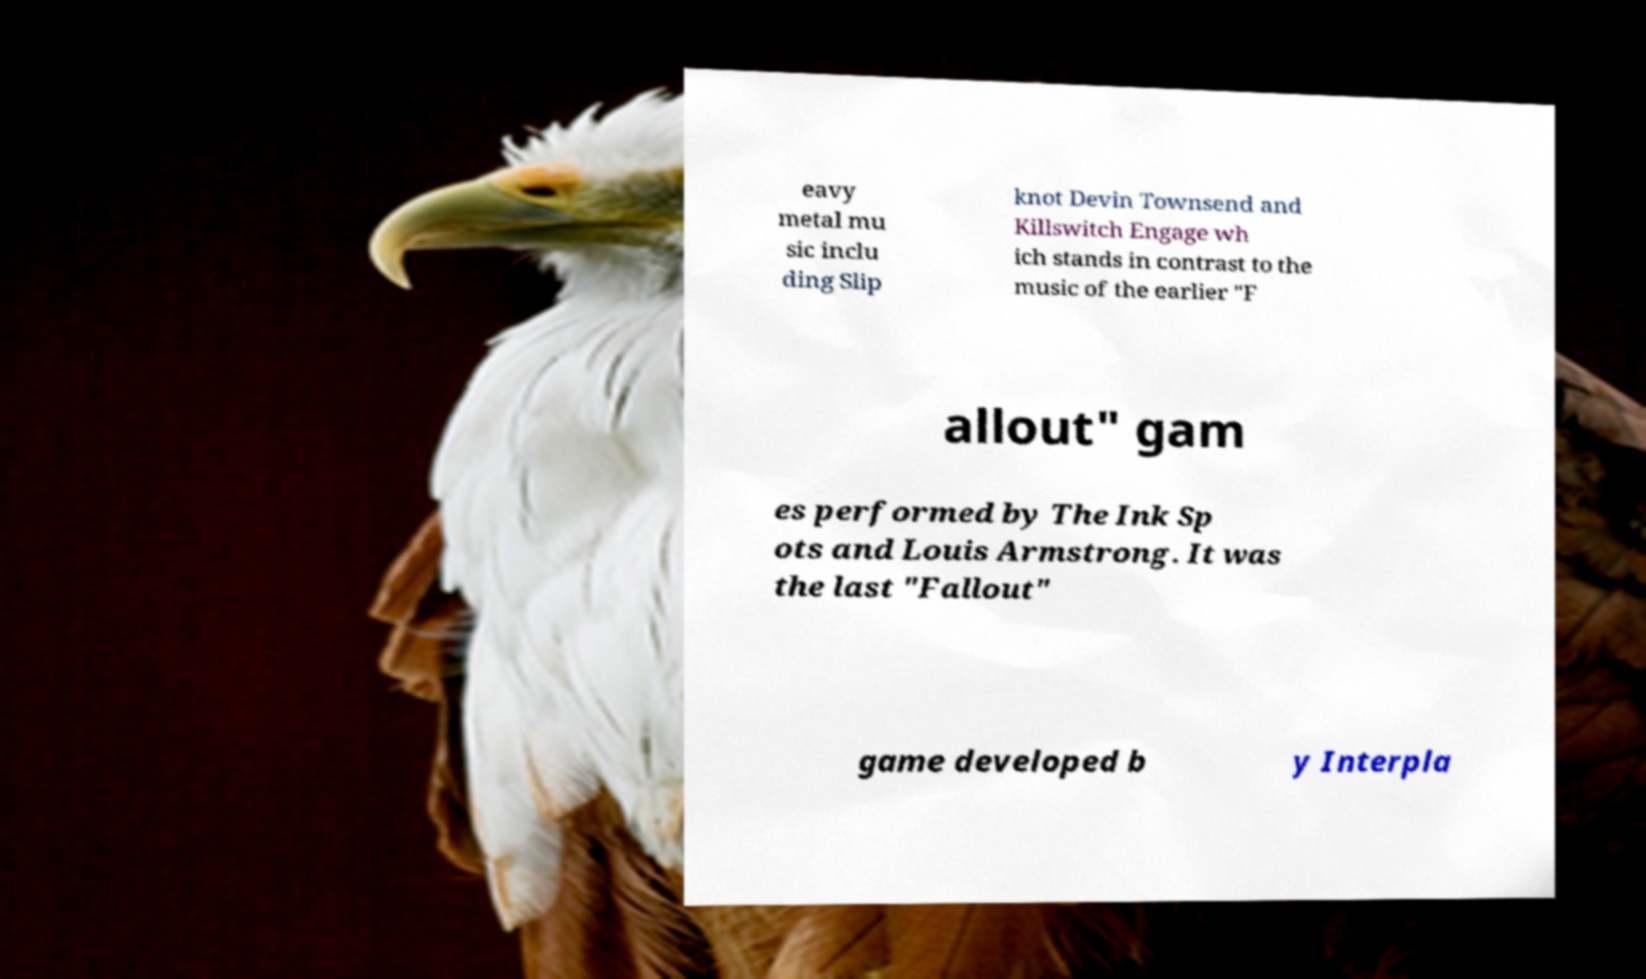Could you extract and type out the text from this image? eavy metal mu sic inclu ding Slip knot Devin Townsend and Killswitch Engage wh ich stands in contrast to the music of the earlier "F allout" gam es performed by The Ink Sp ots and Louis Armstrong. It was the last "Fallout" game developed b y Interpla 